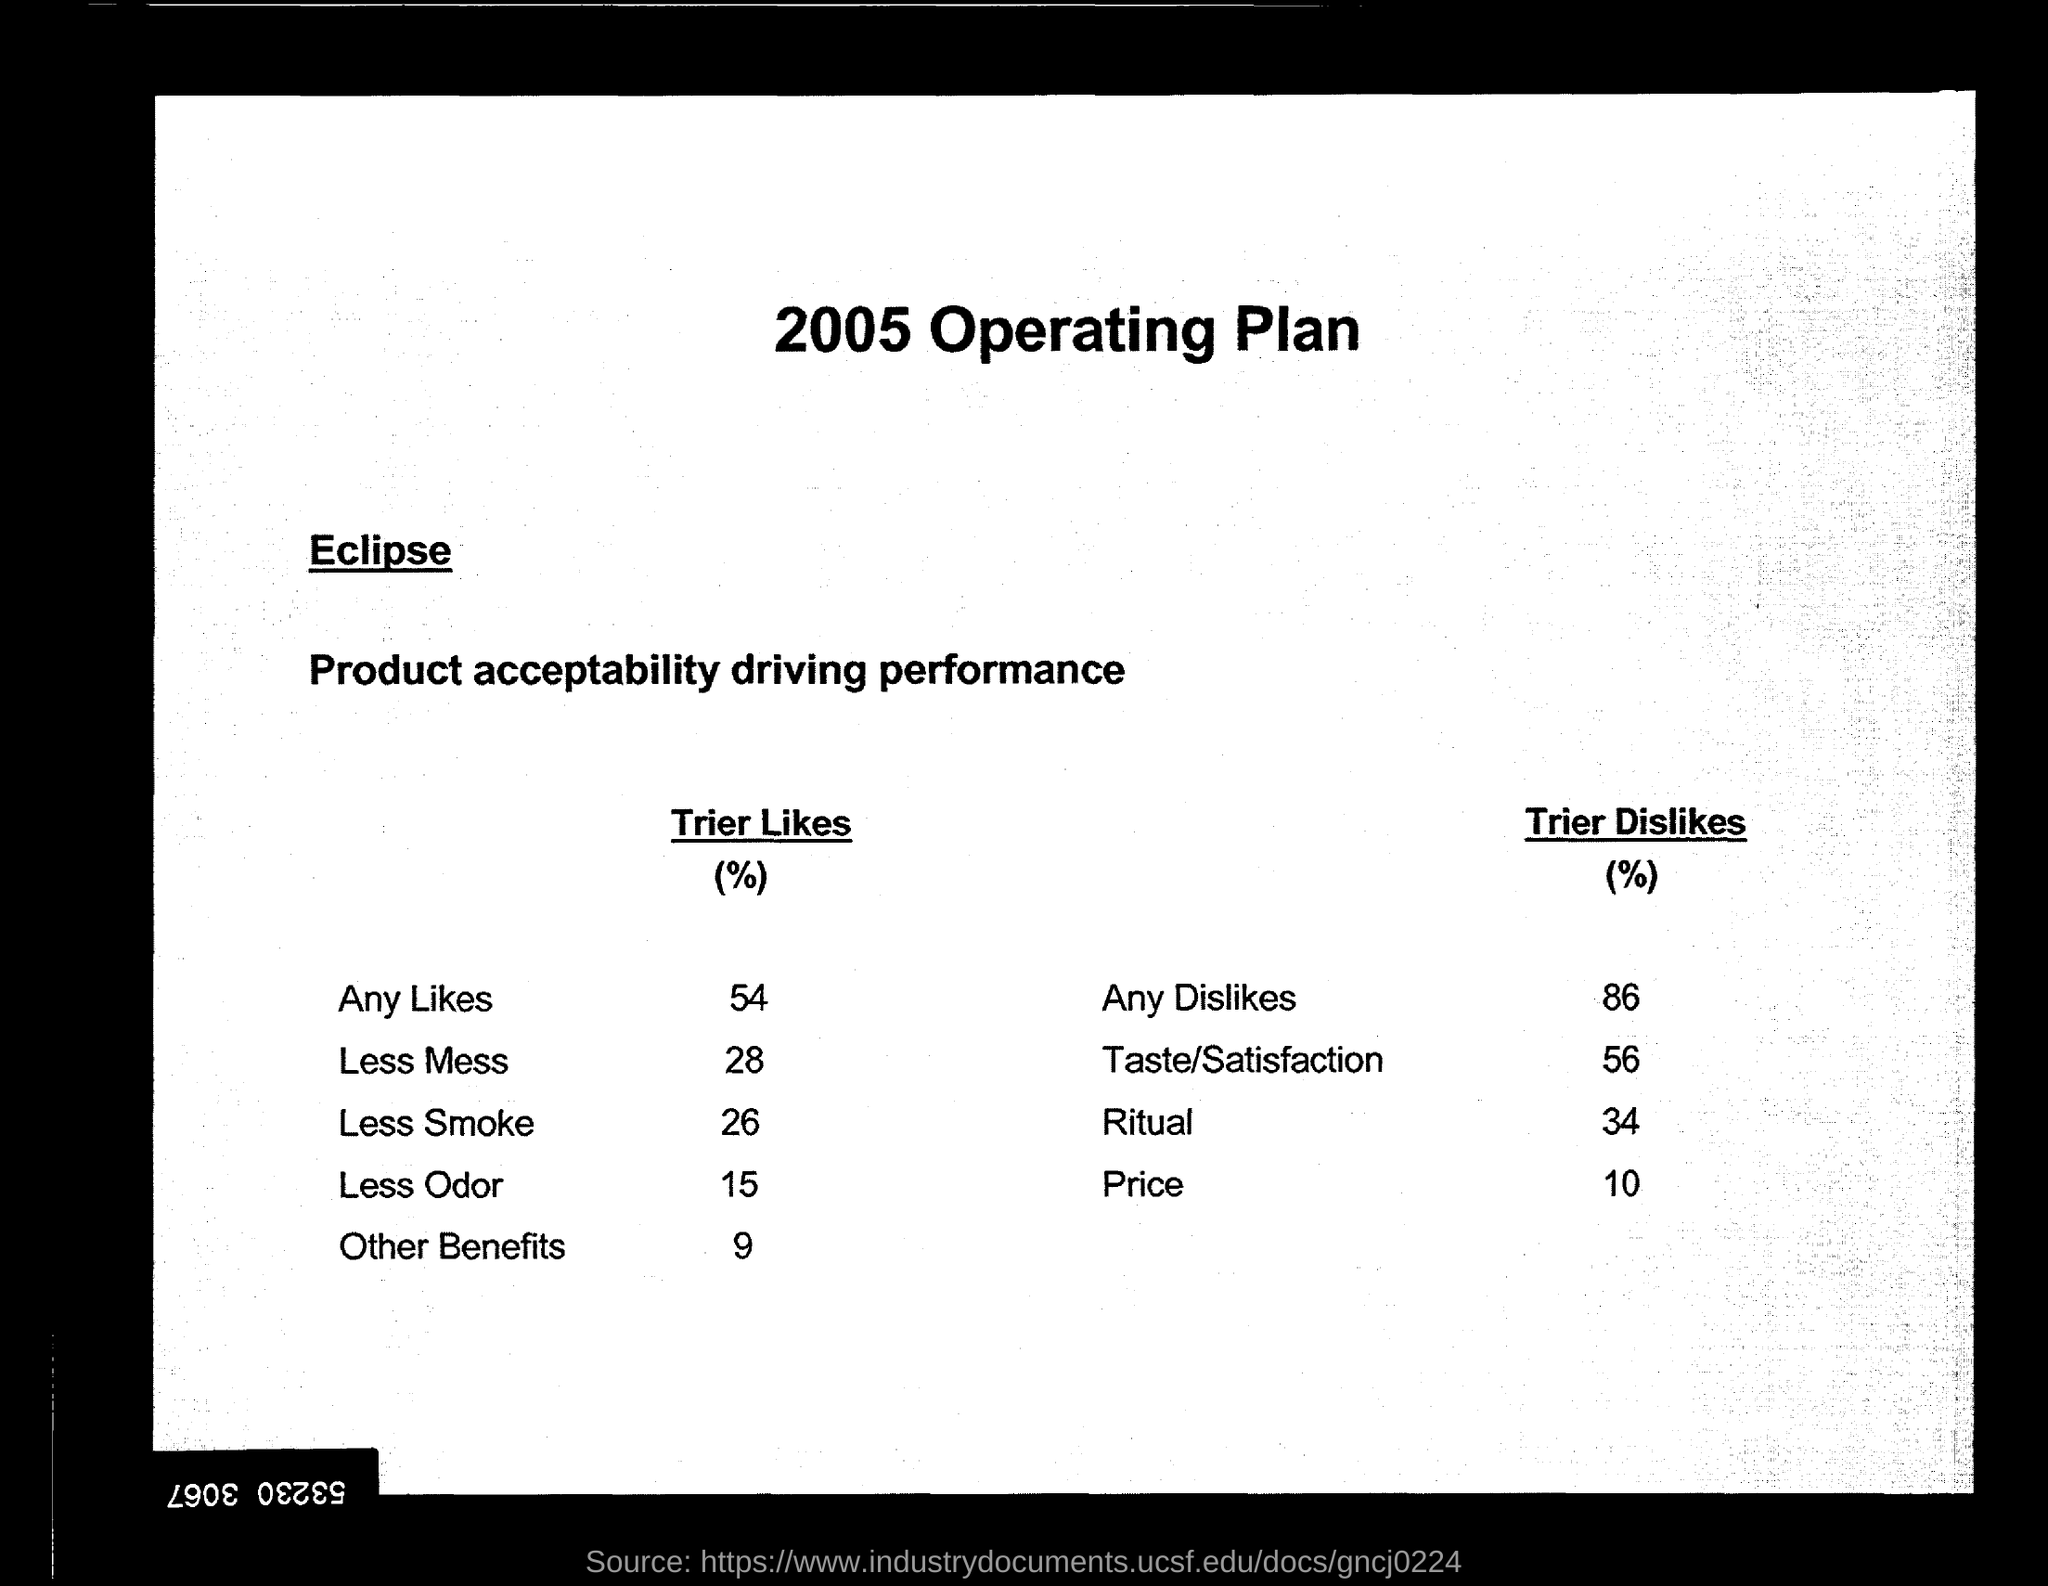What is the "Trier Likes" % for "Less Smoke"?
Keep it short and to the point. 26. What is the "Trier DisLikes" % for "Ritual"?
Keep it short and to the point. 34. What is the "Trier Likes" % for "Less Odor"?
Ensure brevity in your answer.  15. What is the "Trier Likes" % for "Less Mess"?
Ensure brevity in your answer.  28. 